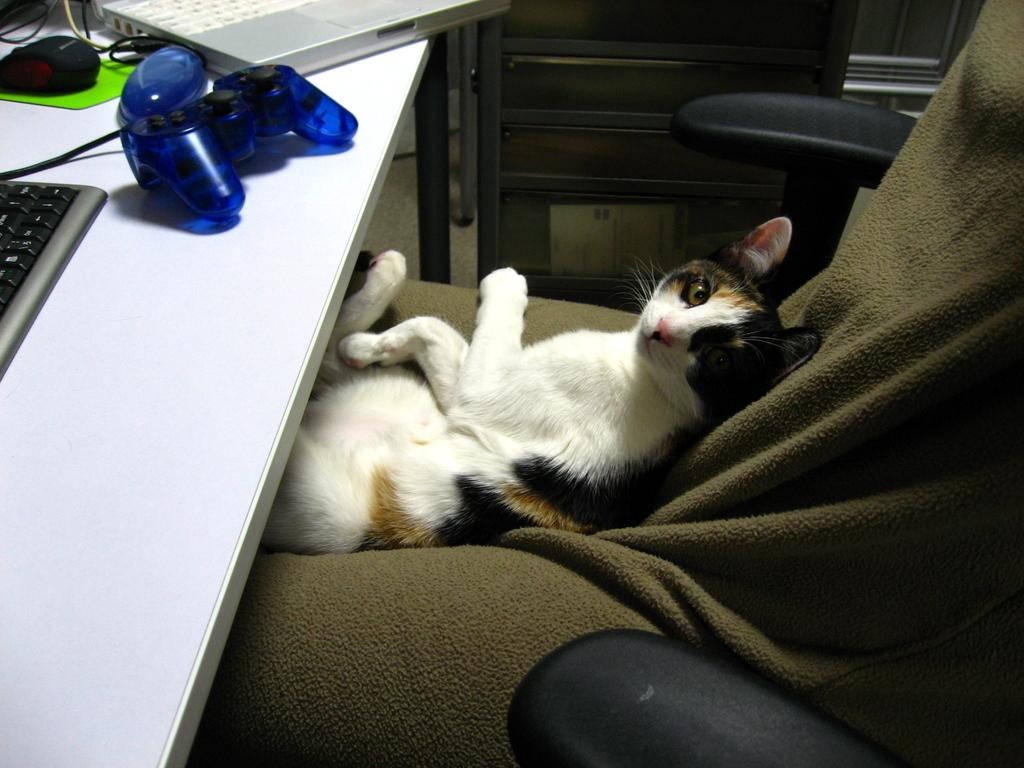What animal is sitting on a chair in the image? There is a cat sitting on a chair in the image. What object is on the table in the image? There is a joystick and a mouse on the table in the image. What electronic device is on the table in the image? There is a laptop on the table in the image. What type of haircut is the cat getting in the image? There is no haircut being given to the cat in the image; it is simply sitting on a chair. What is being exchanged between the cat and the laptop in the image? There is no exchange happening between the cat and the laptop in the image; the cat is just sitting on the chair, and the laptop is on the table. 